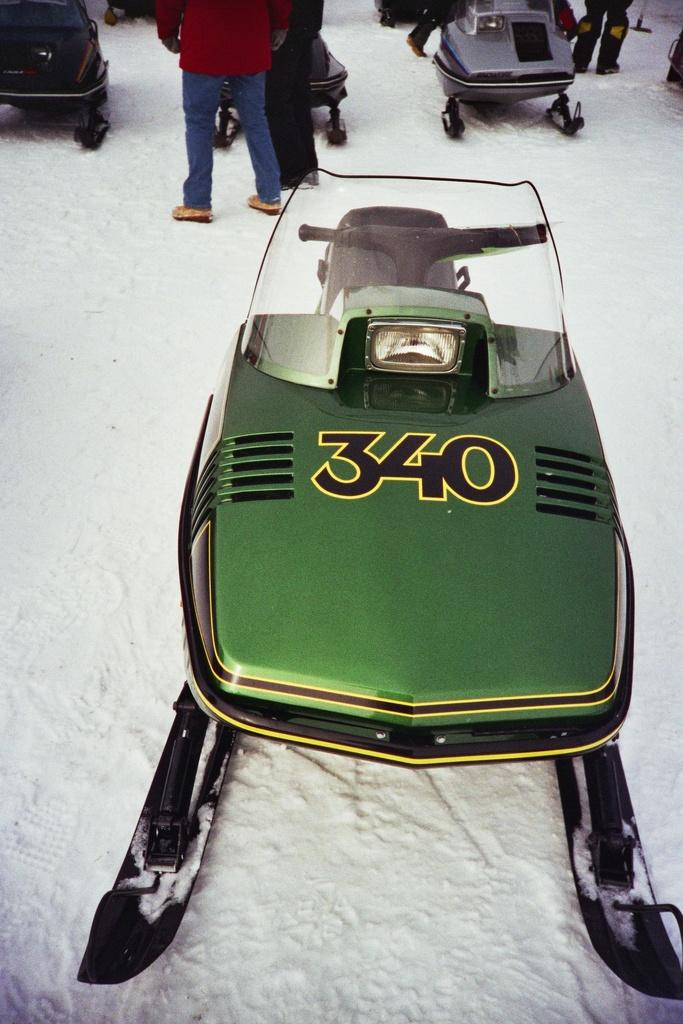What is the main subject in the foreground of the image? There is a snowmobile in the foreground of the image. What type of terrain is the snowmobile on? The snowmobile is on a snowy land. Are there any people visible in the image? Yes, there are people in the image. What else can be seen in the image besides the snowmobile in the foreground? There are additional snowmobiles at the top side of the image. What is the aftermath of the moon landing in the image? There is no reference to a moon landing in the image, so it's not possible to determine the aftermath of such an event. 